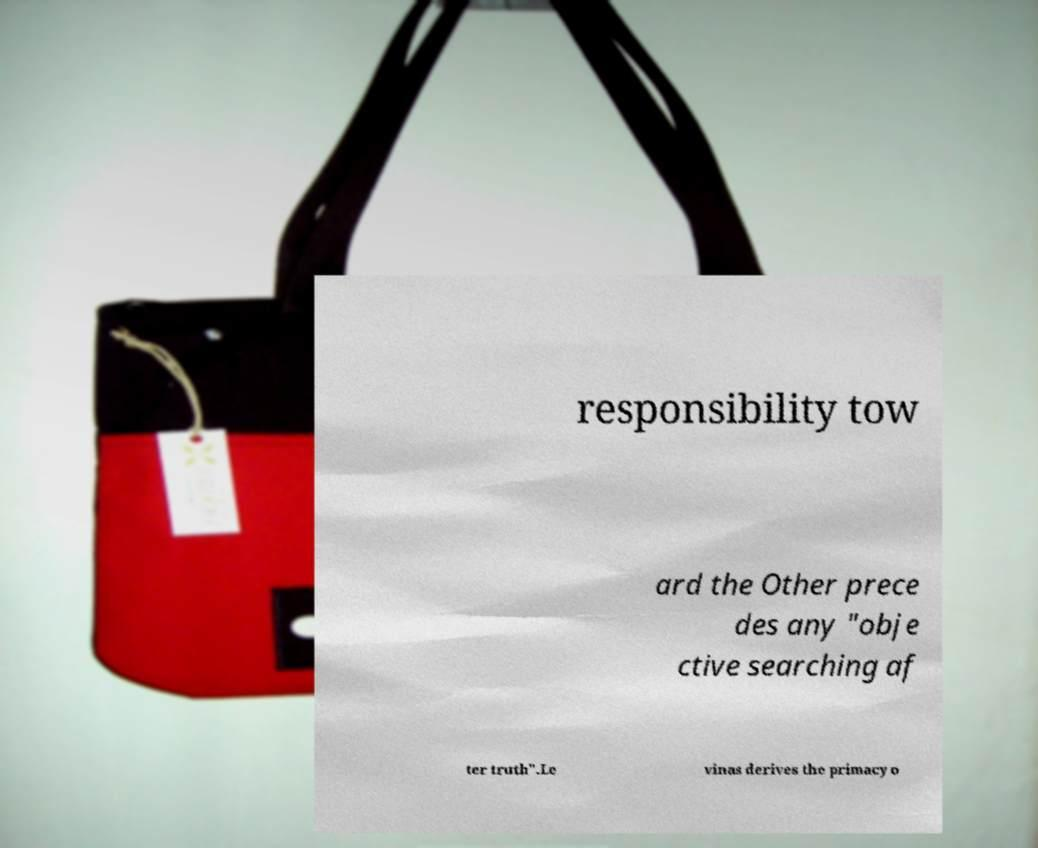Please read and relay the text visible in this image. What does it say? responsibility tow ard the Other prece des any "obje ctive searching af ter truth".Le vinas derives the primacy o 